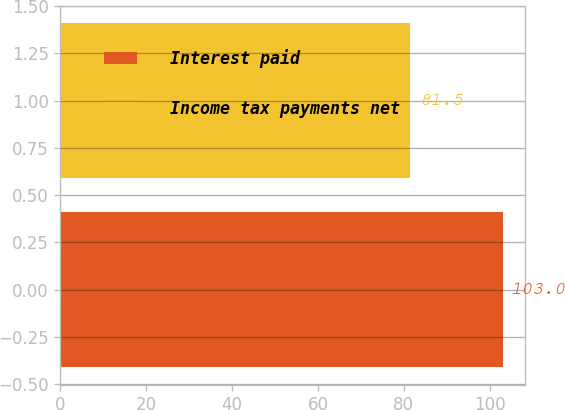<chart> <loc_0><loc_0><loc_500><loc_500><bar_chart><fcel>Interest paid<fcel>Income tax payments net<nl><fcel>103<fcel>81.5<nl></chart> 